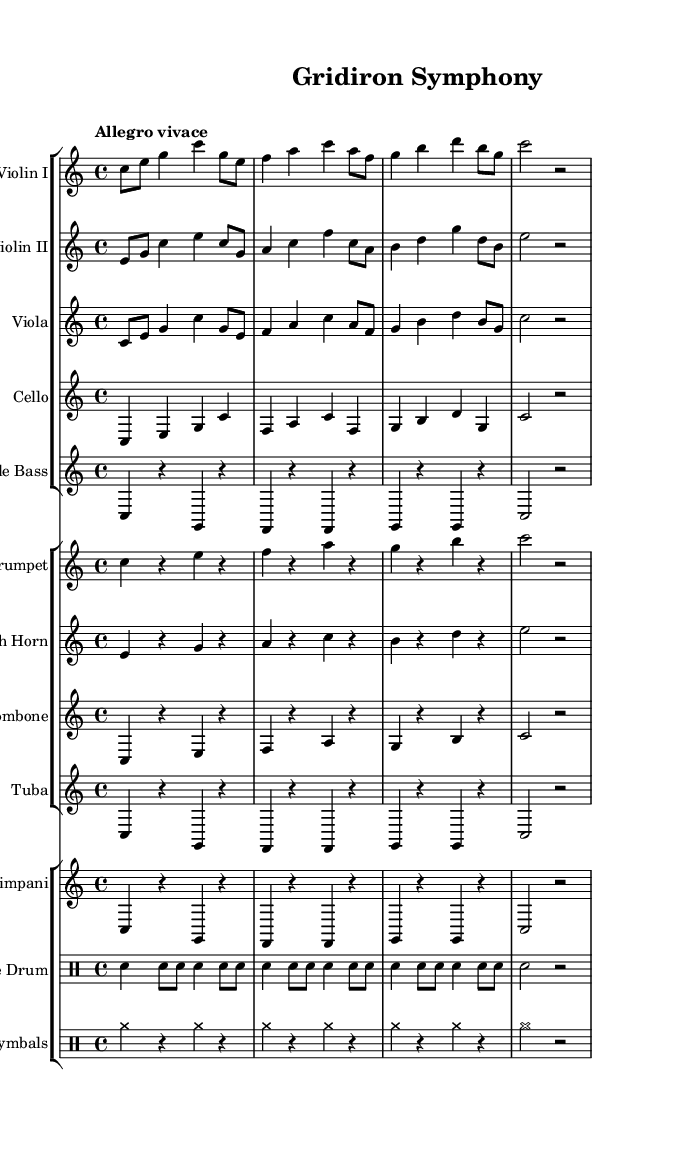What is the key signature of this music? The key signature is located at the beginning of the sheet music. It indicates C major, which has no sharps or flats.
Answer: C major What is the time signature of the piece? The time signature is indicated in the beginning section of the music. It shows the piece is in 4/4, meaning there are four beats in a measure.
Answer: 4/4 What is the tempo marking for this symphony? The tempo marking is shown above the staff in the first section of the score. It is marked as "Allegro vivace," indicating a fast and lively pace.
Answer: Allegro vivace How many instruments are used in this symphony? By counting the groups of staffs, we see there are four groups of instruments, specifically violins, brass, and percussion, indicating a total of eight distinct instruments.
Answer: Eight In which section is the snare drum featured? The snare drum appears in the third group of the score, which is labeled "DrumStaff," indicating its position within the percussion section.
Answer: Third group What type of music is this score categorized as? This score is categorized as a symphony, specifically inspired by the energy and excitement of football games, which is reflected in the thematic music elements.
Answer: Symphony 